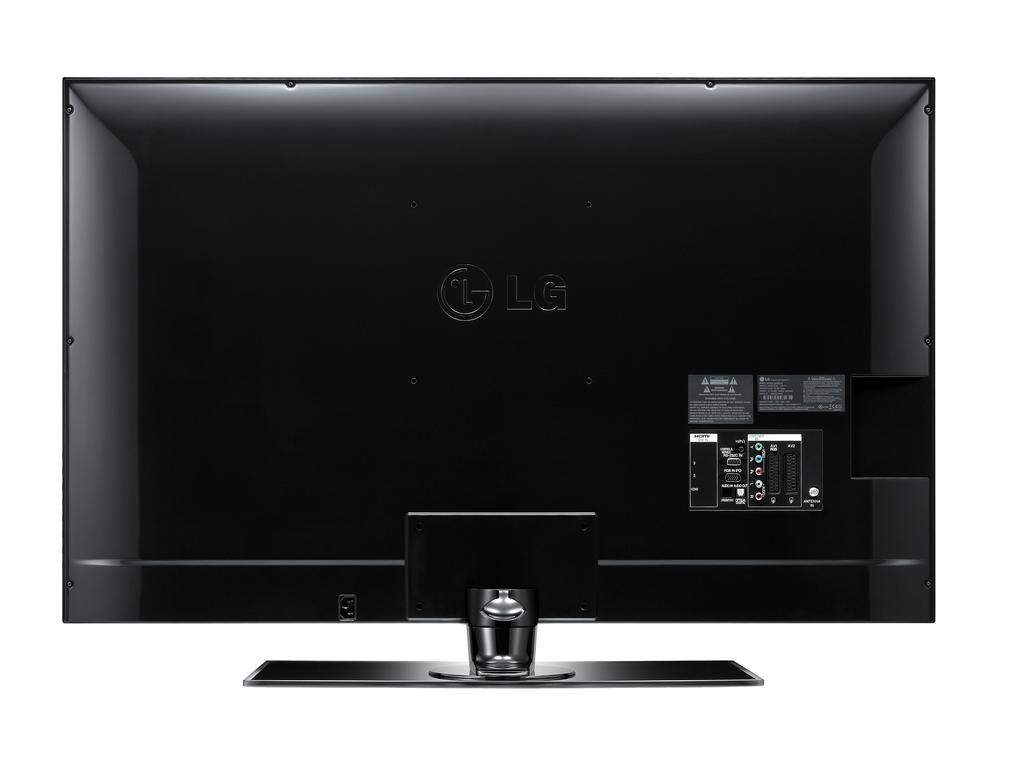Provide a one-sentence caption for the provided image. an LG monitor that is all black in color. 